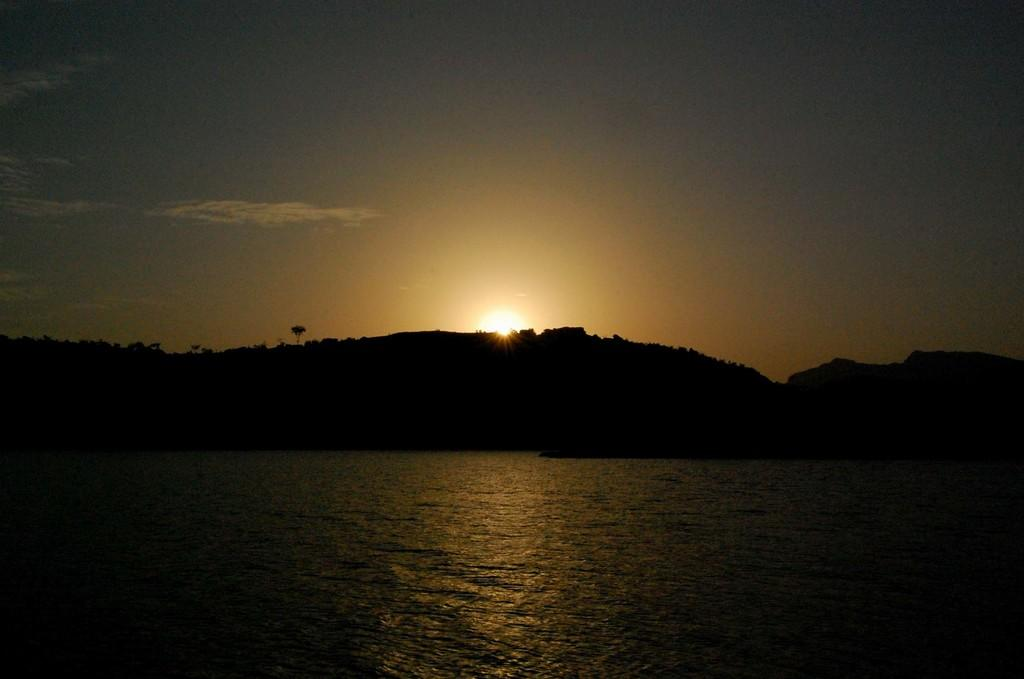What is visible in the image? Water is visible in the image. What can be seen in the background of the image? There are hills in the background of the image. What is visible in the sky in the image? The sky is visible in the image, and the sun is observable. What type of wool is being used to create the umbrella in the image? There is no umbrella present in the image, so it is not possible to determine the type of wool being used. 